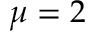Convert formula to latex. <formula><loc_0><loc_0><loc_500><loc_500>\mu = 2</formula> 